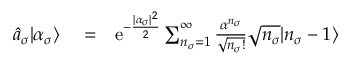Convert formula to latex. <formula><loc_0><loc_0><loc_500><loc_500>\begin{array} { r l r } { \hat { a } _ { \sigma } | \alpha _ { \sigma } \rangle } & = } & { e ^ { - \frac { | \alpha _ { \sigma } | ^ { 2 } } { 2 } } \sum _ { n _ { \sigma } = 1 } ^ { \infty } \frac { \alpha ^ { n _ { \sigma } } } { \sqrt { n _ { \sigma } ! } } \sqrt { n _ { \sigma } } | n _ { \sigma } - 1 \rangle } \end{array}</formula> 